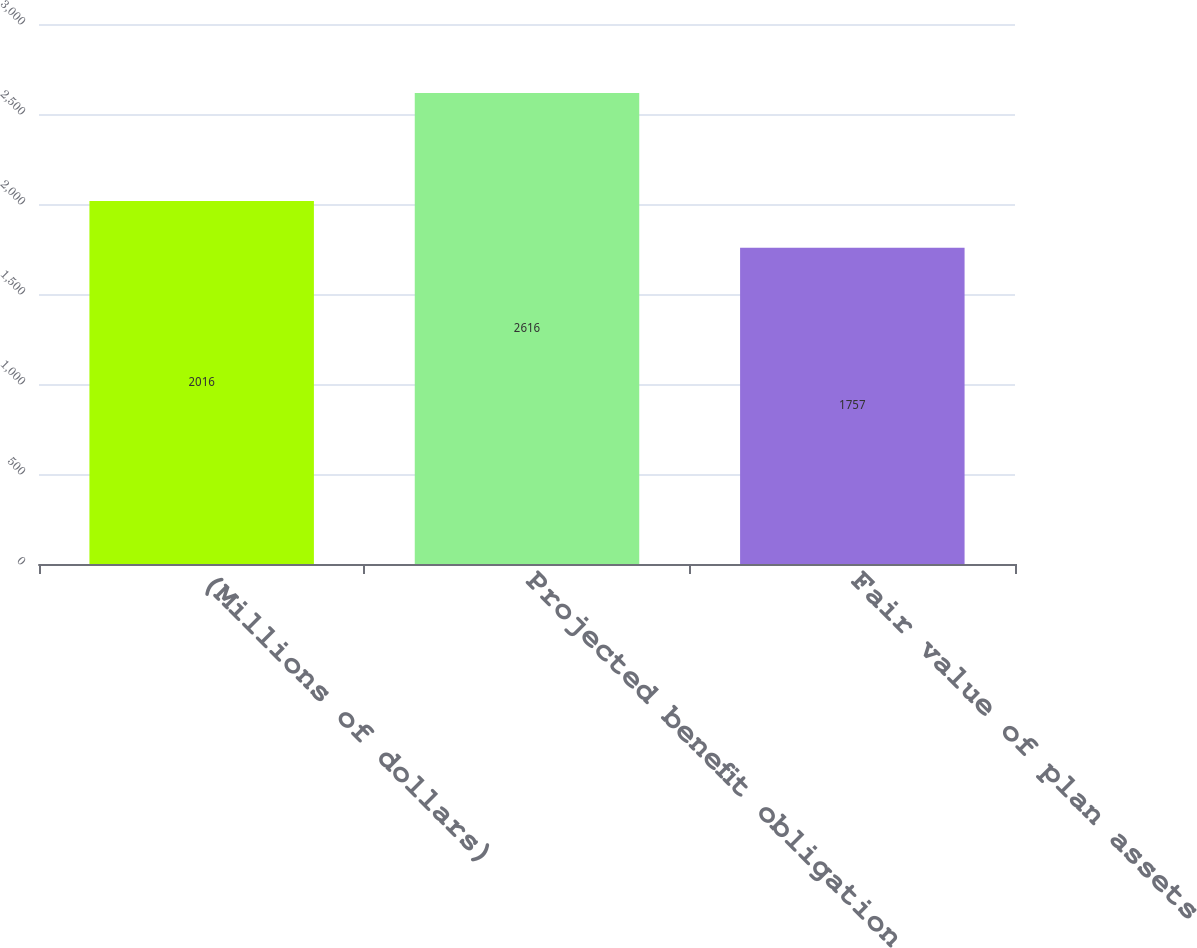Convert chart to OTSL. <chart><loc_0><loc_0><loc_500><loc_500><bar_chart><fcel>(Millions of dollars)<fcel>Projected benefit obligation<fcel>Fair value of plan assets<nl><fcel>2016<fcel>2616<fcel>1757<nl></chart> 